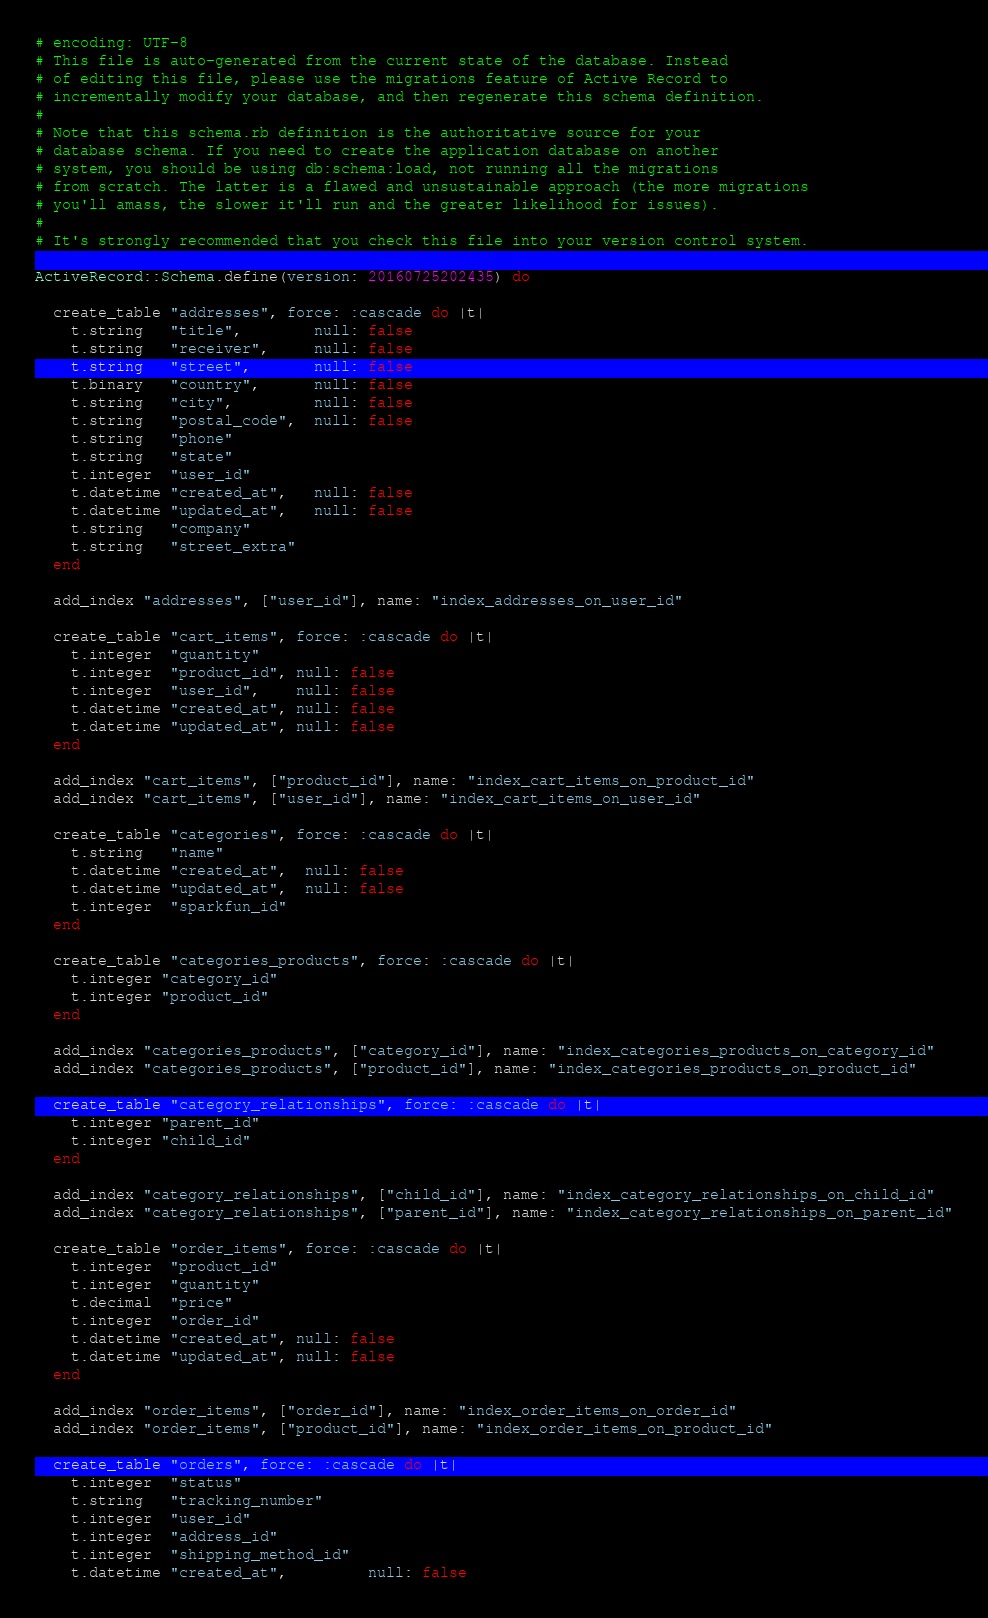Convert code to text. <code><loc_0><loc_0><loc_500><loc_500><_Ruby_># encoding: UTF-8
# This file is auto-generated from the current state of the database. Instead
# of editing this file, please use the migrations feature of Active Record to
# incrementally modify your database, and then regenerate this schema definition.
#
# Note that this schema.rb definition is the authoritative source for your
# database schema. If you need to create the application database on another
# system, you should be using db:schema:load, not running all the migrations
# from scratch. The latter is a flawed and unsustainable approach (the more migrations
# you'll amass, the slower it'll run and the greater likelihood for issues).
#
# It's strongly recommended that you check this file into your version control system.

ActiveRecord::Schema.define(version: 20160725202435) do

  create_table "addresses", force: :cascade do |t|
    t.string   "title",        null: false
    t.string   "receiver",     null: false
    t.string   "street",       null: false
    t.binary   "country",      null: false
    t.string   "city",         null: false
    t.string   "postal_code",  null: false
    t.string   "phone"
    t.string   "state"
    t.integer  "user_id"
    t.datetime "created_at",   null: false
    t.datetime "updated_at",   null: false
    t.string   "company"
    t.string   "street_extra"
  end

  add_index "addresses", ["user_id"], name: "index_addresses_on_user_id"

  create_table "cart_items", force: :cascade do |t|
    t.integer  "quantity"
    t.integer  "product_id", null: false
    t.integer  "user_id",    null: false
    t.datetime "created_at", null: false
    t.datetime "updated_at", null: false
  end

  add_index "cart_items", ["product_id"], name: "index_cart_items_on_product_id"
  add_index "cart_items", ["user_id"], name: "index_cart_items_on_user_id"

  create_table "categories", force: :cascade do |t|
    t.string   "name"
    t.datetime "created_at",  null: false
    t.datetime "updated_at",  null: false
    t.integer  "sparkfun_id"
  end

  create_table "categories_products", force: :cascade do |t|
    t.integer "category_id"
    t.integer "product_id"
  end

  add_index "categories_products", ["category_id"], name: "index_categories_products_on_category_id"
  add_index "categories_products", ["product_id"], name: "index_categories_products_on_product_id"

  create_table "category_relationships", force: :cascade do |t|
    t.integer "parent_id"
    t.integer "child_id"
  end

  add_index "category_relationships", ["child_id"], name: "index_category_relationships_on_child_id"
  add_index "category_relationships", ["parent_id"], name: "index_category_relationships_on_parent_id"

  create_table "order_items", force: :cascade do |t|
    t.integer  "product_id"
    t.integer  "quantity"
    t.decimal  "price"
    t.integer  "order_id"
    t.datetime "created_at", null: false
    t.datetime "updated_at", null: false
  end

  add_index "order_items", ["order_id"], name: "index_order_items_on_order_id"
  add_index "order_items", ["product_id"], name: "index_order_items_on_product_id"

  create_table "orders", force: :cascade do |t|
    t.integer  "status"
    t.string   "tracking_number"
    t.integer  "user_id"
    t.integer  "address_id"
    t.integer  "shipping_method_id"
    t.datetime "created_at",         null: false</code> 